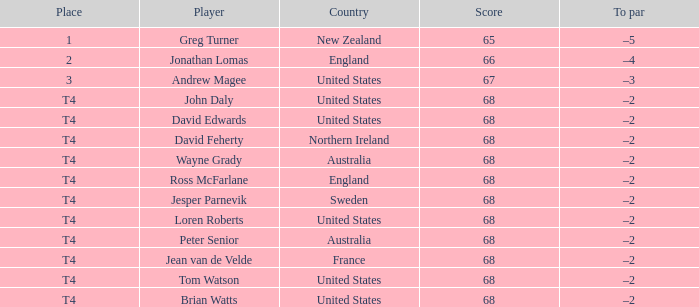Who has a To par of –2, and a Country of united states? John Daly, David Edwards, Loren Roberts, Tom Watson, Brian Watts. 